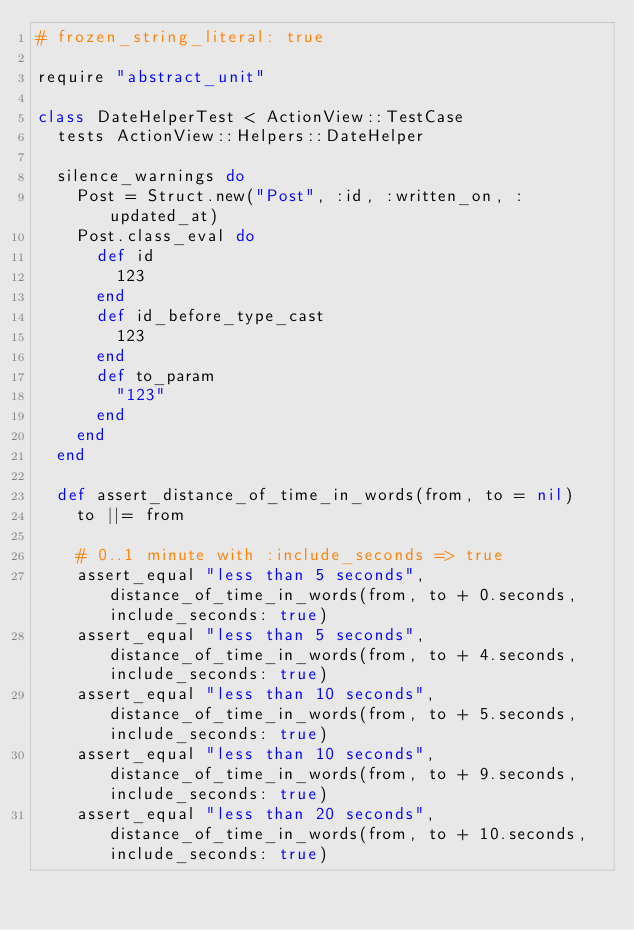<code> <loc_0><loc_0><loc_500><loc_500><_Ruby_># frozen_string_literal: true

require "abstract_unit"

class DateHelperTest < ActionView::TestCase
  tests ActionView::Helpers::DateHelper

  silence_warnings do
    Post = Struct.new("Post", :id, :written_on, :updated_at)
    Post.class_eval do
      def id
        123
      end
      def id_before_type_cast
        123
      end
      def to_param
        "123"
      end
    end
  end

  def assert_distance_of_time_in_words(from, to = nil)
    to ||= from

    # 0..1 minute with :include_seconds => true
    assert_equal "less than 5 seconds", distance_of_time_in_words(from, to + 0.seconds, include_seconds: true)
    assert_equal "less than 5 seconds", distance_of_time_in_words(from, to + 4.seconds, include_seconds: true)
    assert_equal "less than 10 seconds", distance_of_time_in_words(from, to + 5.seconds, include_seconds: true)
    assert_equal "less than 10 seconds", distance_of_time_in_words(from, to + 9.seconds, include_seconds: true)
    assert_equal "less than 20 seconds", distance_of_time_in_words(from, to + 10.seconds, include_seconds: true)</code> 